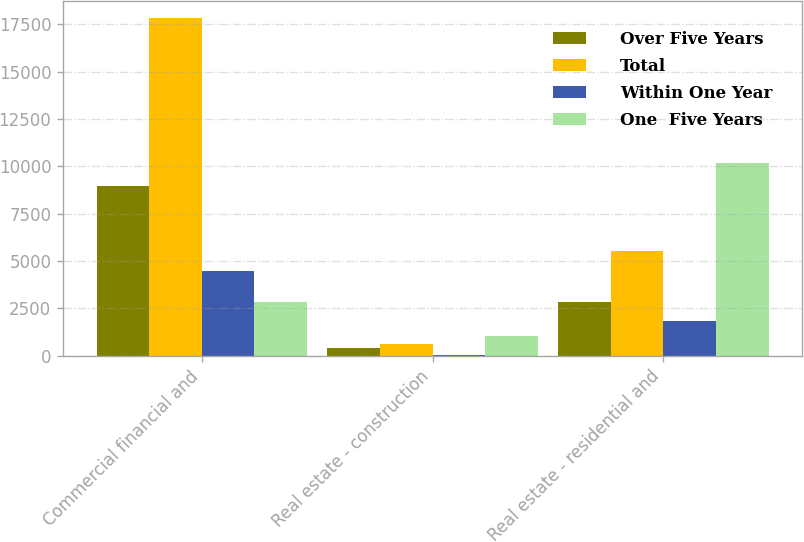Convert chart to OTSL. <chart><loc_0><loc_0><loc_500><loc_500><stacked_bar_chart><ecel><fcel>Commercial financial and<fcel>Real estate - construction<fcel>Real estate - residential and<nl><fcel>Over Five Years<fcel>8942<fcel>432<fcel>2838<nl><fcel>Total<fcel>17845<fcel>596<fcel>5549<nl><fcel>Within One Year<fcel>4453<fcel>25<fcel>1814<nl><fcel>One  Five Years<fcel>2838<fcel>1053<fcel>10201<nl></chart> 